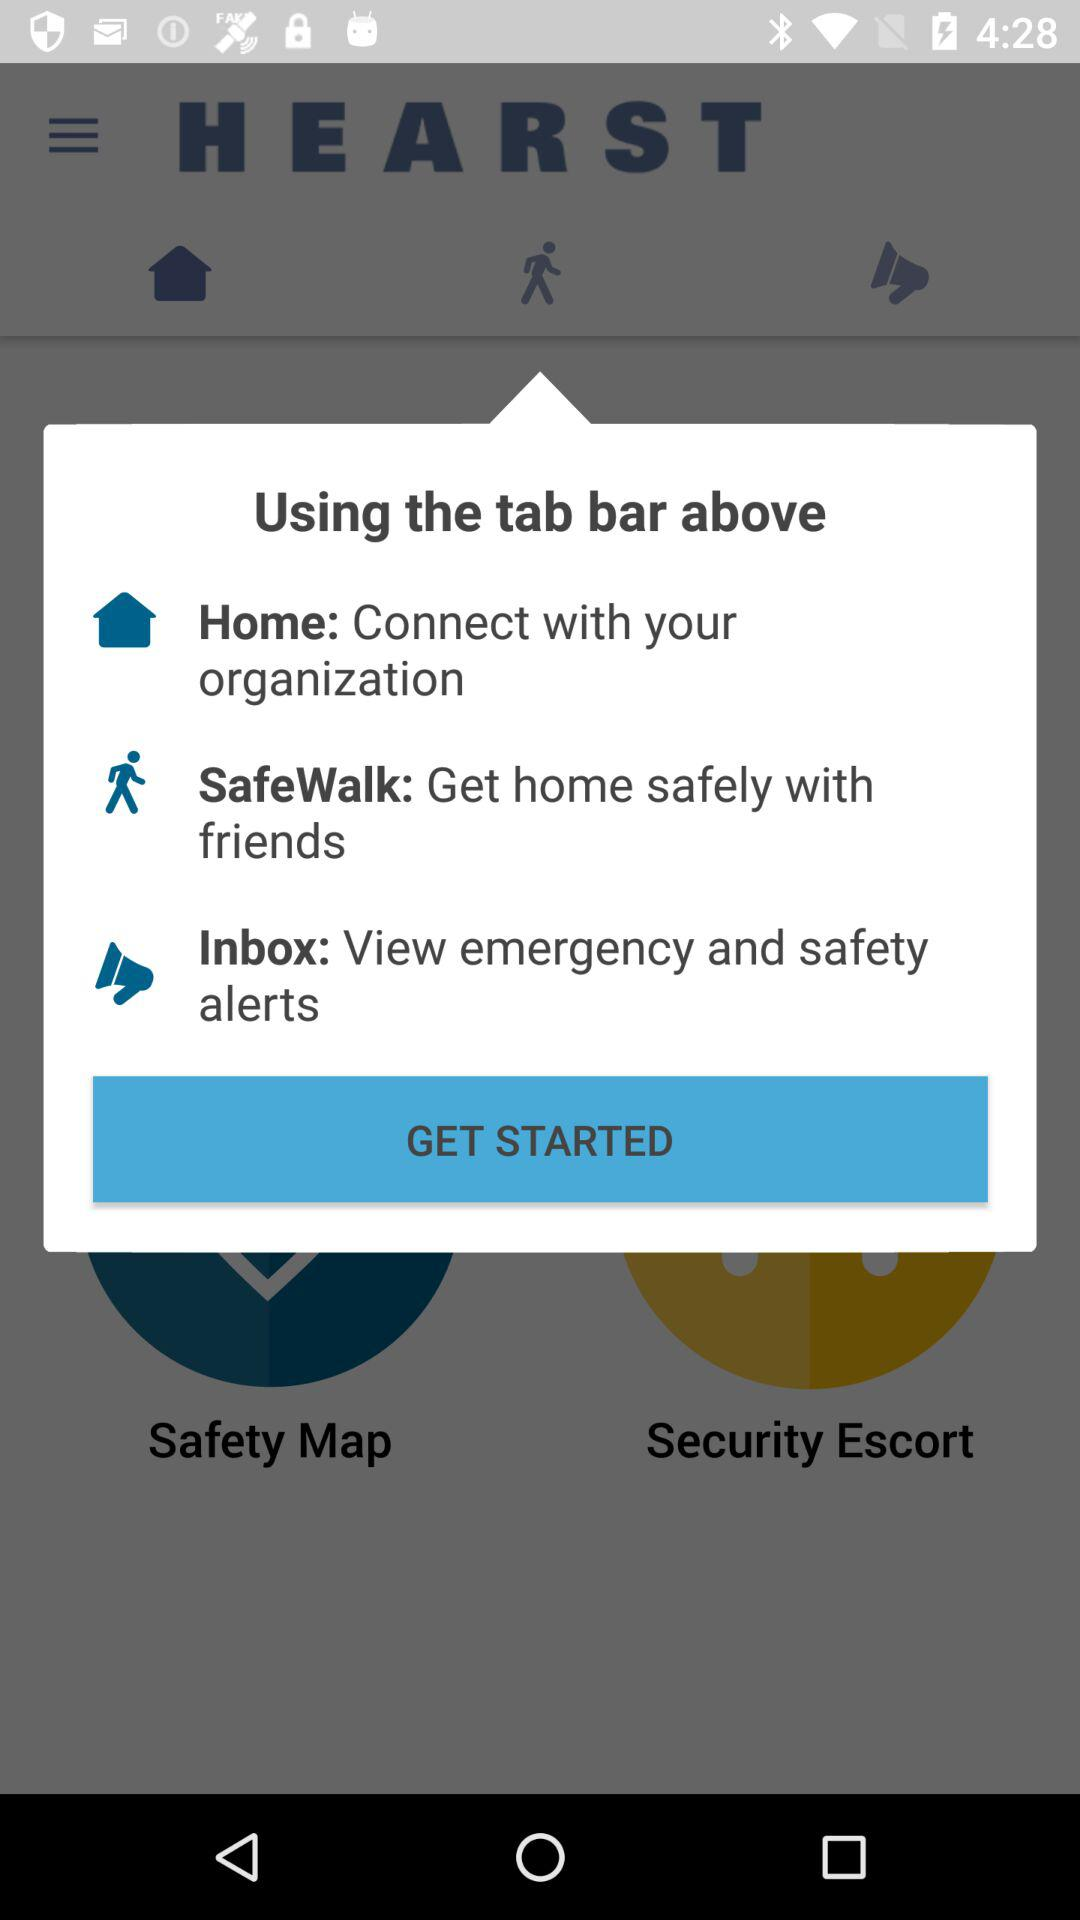What kinds of alerts can be viewed in "Inbox"? In "Inbox", emergency and safety alerts can be viewed. 